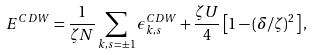Convert formula to latex. <formula><loc_0><loc_0><loc_500><loc_500>E ^ { C D W } = \frac { 1 } { \zeta N } \sum _ { { k } , s = \pm 1 } \epsilon ^ { C D W } _ { { k } , s } + \frac { \zeta U } { 4 } \left [ 1 - ( \delta / \zeta ) ^ { 2 } \right ] ,</formula> 